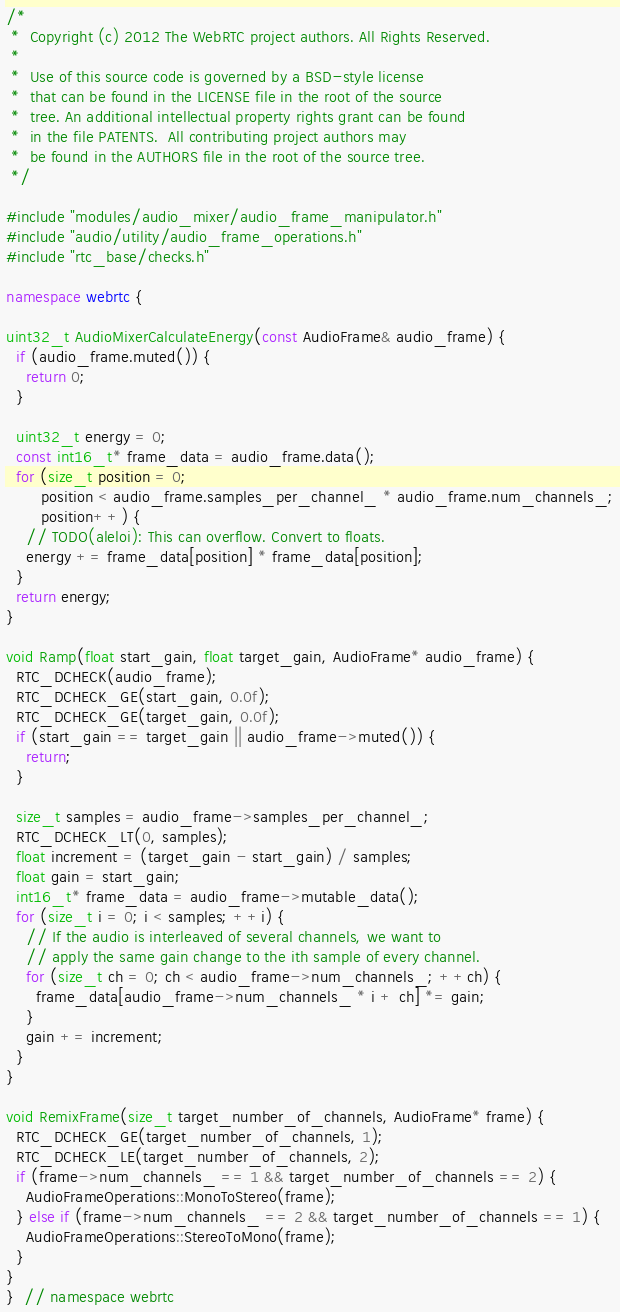<code> <loc_0><loc_0><loc_500><loc_500><_C++_>/*
 *  Copyright (c) 2012 The WebRTC project authors. All Rights Reserved.
 *
 *  Use of this source code is governed by a BSD-style license
 *  that can be found in the LICENSE file in the root of the source
 *  tree. An additional intellectual property rights grant can be found
 *  in the file PATENTS.  All contributing project authors may
 *  be found in the AUTHORS file in the root of the source tree.
 */

#include "modules/audio_mixer/audio_frame_manipulator.h"
#include "audio/utility/audio_frame_operations.h"
#include "rtc_base/checks.h"

namespace webrtc {

uint32_t AudioMixerCalculateEnergy(const AudioFrame& audio_frame) {
  if (audio_frame.muted()) {
    return 0;
  }

  uint32_t energy = 0;
  const int16_t* frame_data = audio_frame.data();
  for (size_t position = 0;
       position < audio_frame.samples_per_channel_ * audio_frame.num_channels_;
       position++) {
    // TODO(aleloi): This can overflow. Convert to floats.
    energy += frame_data[position] * frame_data[position];
  }
  return energy;
}

void Ramp(float start_gain, float target_gain, AudioFrame* audio_frame) {
  RTC_DCHECK(audio_frame);
  RTC_DCHECK_GE(start_gain, 0.0f);
  RTC_DCHECK_GE(target_gain, 0.0f);
  if (start_gain == target_gain || audio_frame->muted()) {
    return;
  }

  size_t samples = audio_frame->samples_per_channel_;
  RTC_DCHECK_LT(0, samples);
  float increment = (target_gain - start_gain) / samples;
  float gain = start_gain;
  int16_t* frame_data = audio_frame->mutable_data();
  for (size_t i = 0; i < samples; ++i) {
    // If the audio is interleaved of several channels, we want to
    // apply the same gain change to the ith sample of every channel.
    for (size_t ch = 0; ch < audio_frame->num_channels_; ++ch) {
      frame_data[audio_frame->num_channels_ * i + ch] *= gain;
    }
    gain += increment;
  }
}

void RemixFrame(size_t target_number_of_channels, AudioFrame* frame) {
  RTC_DCHECK_GE(target_number_of_channels, 1);
  RTC_DCHECK_LE(target_number_of_channels, 2);
  if (frame->num_channels_ == 1 && target_number_of_channels == 2) {
    AudioFrameOperations::MonoToStereo(frame);
  } else if (frame->num_channels_ == 2 && target_number_of_channels == 1) {
    AudioFrameOperations::StereoToMono(frame);
  }
}
}  // namespace webrtc
</code> 